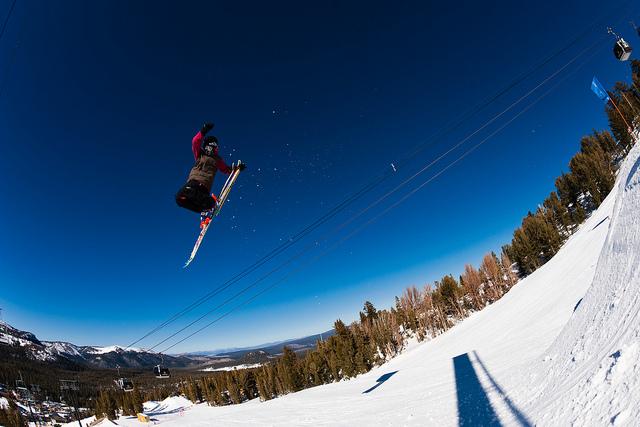What is on the ground?
Answer briefly. Snow. What activity is this person doing?
Answer briefly. Skiing. Is this a professional skier?
Write a very short answer. Yes. Is this an extreme sport?
Quick response, please. Yes. Does this person have a good sense of balance?
Keep it brief. Yes. What is the snowboarder on?
Be succinct. Snowboard. How many people are in the chair lift?
Be succinct. 0. Is the terrain flat?
Quick response, please. No. How did the man get in the air?
Be succinct. Jumping. What is the color of his shirt?
Answer briefly. Red. 